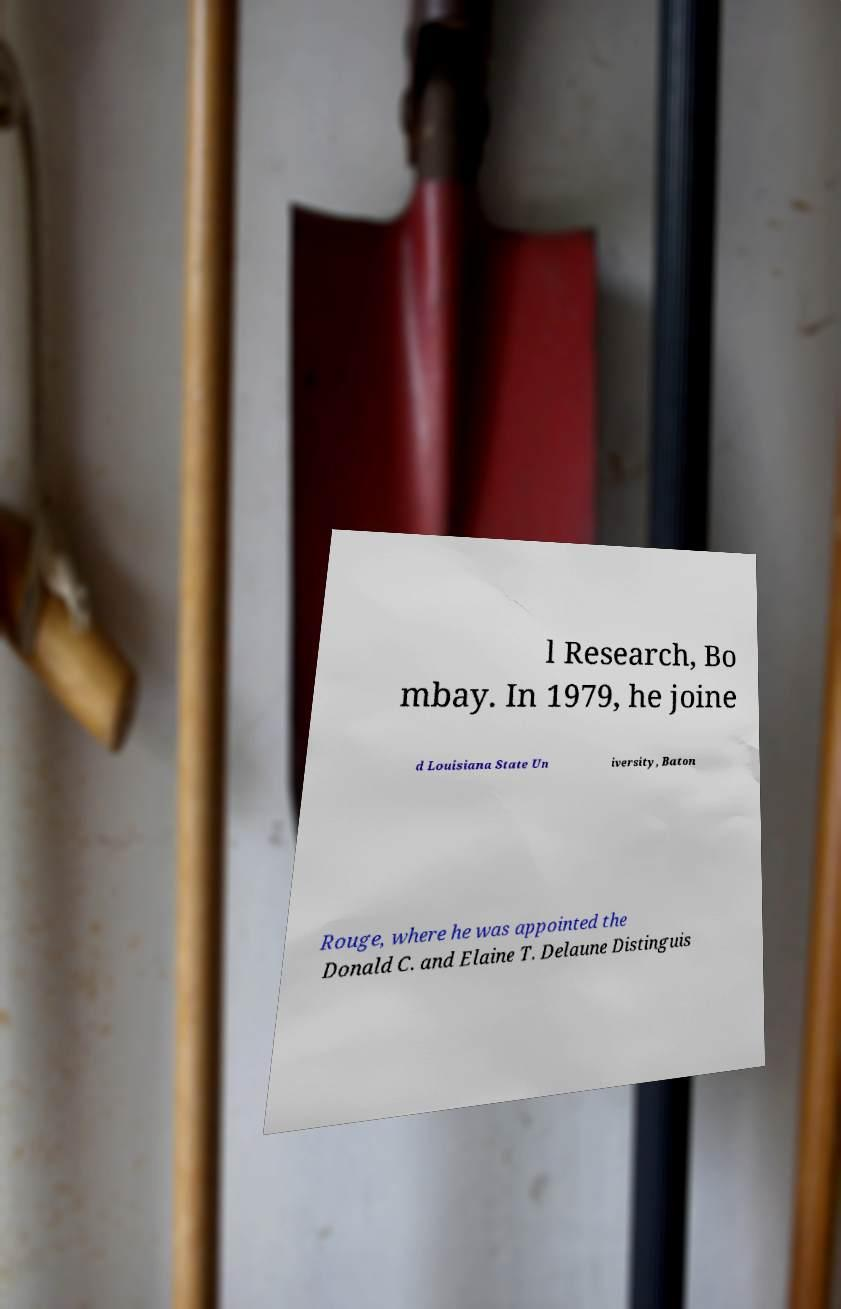Can you accurately transcribe the text from the provided image for me? l Research, Bo mbay. In 1979, he joine d Louisiana State Un iversity, Baton Rouge, where he was appointed the Donald C. and Elaine T. Delaune Distinguis 